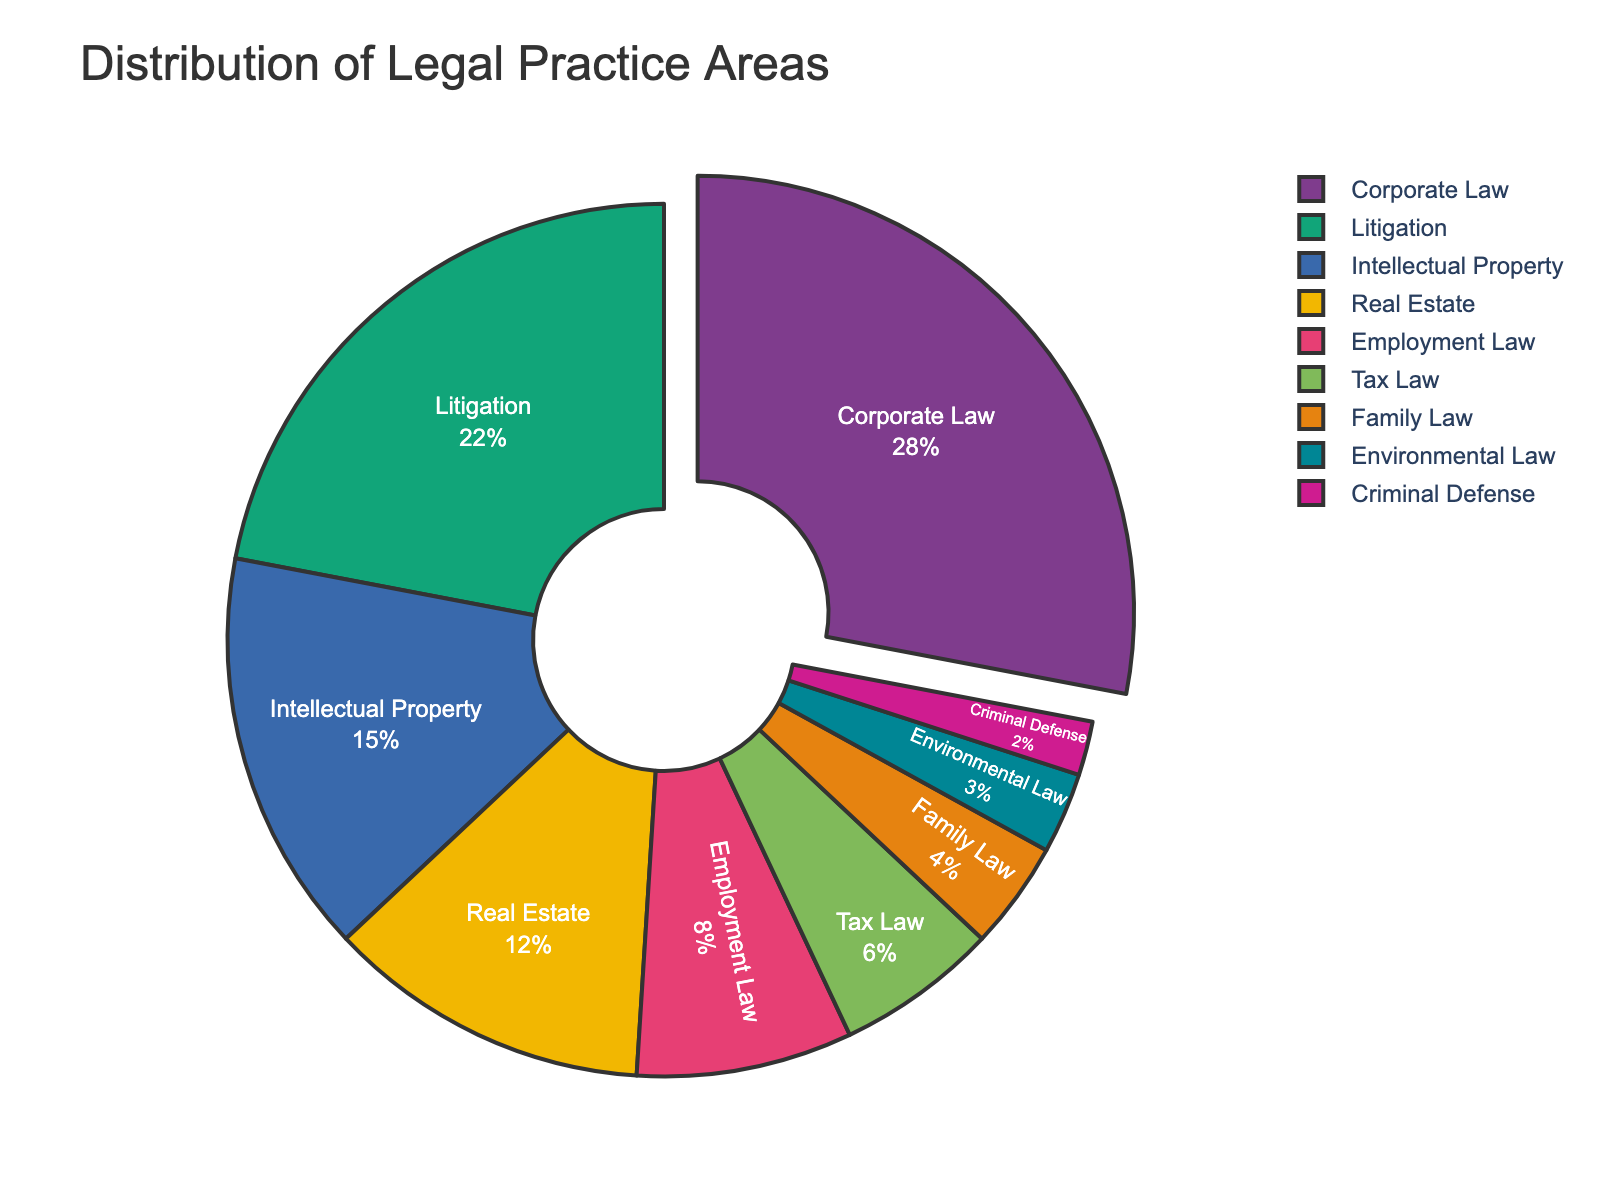Which practice area has the highest percentage? By looking at the pie chart, the segment with the largest area or the first label in the legend indicates the practice area with the highest percentage, which is Corporate Law at 28%.
Answer: Corporate Law What is the combined percentage of Litigation and Intellectual Property? Add the percentages for Litigation (22%) and Intellectual Property (15%) together: 22% + 15% = 37%.
Answer: 37% Which practice area has a smaller percentage, Criminal Defense or Environmental Law? Compare the two percentages: Criminal Defense has 2% and Environmental Law has 3%. 2% is smaller than 3%.
Answer: Criminal Defense How many practice areas have a percentage greater than 10%? Look at the sections with percentages greater than 10%: Corporate Law (28%), Litigation (22%), Intellectual Property (15%), Real Estate (12%) – a total of 4 practice areas.
Answer: 4 What is the difference in percentage between Family Law and Tax Law? Subtract the percentage of Tax Law (6%) from Family Law (4%): 6% - 4% = 2%.
Answer: 2% How many practice areas have a percentage of 5% or less? Identify the sections with percentages of 5% or below: Criminal Defense (2%), Environmental Law (3%), Family Law (4%) – a total of 3 practice areas.
Answer: 3 Which practice area is between 5% and 10%? Check for the section with a percentage in the range of 5% to 10%: Employment Law is 8%, fitting this range.
Answer: Employment Law What is the combined percentage of the smallest three practice areas? Sum the percentages of the three smallest areas: Criminal Defense (2%), Environmental Law (3%), Family Law (4%): 2% + 3% + 4% = 9%.
Answer: 9% Which practice area immediately follows Real Estate in percentage? According to the chart, Employment Law follows Real Estate, with Real Estate at 12% and Employment Law at 8%, being the next higher percentage.
Answer: Employment Law 